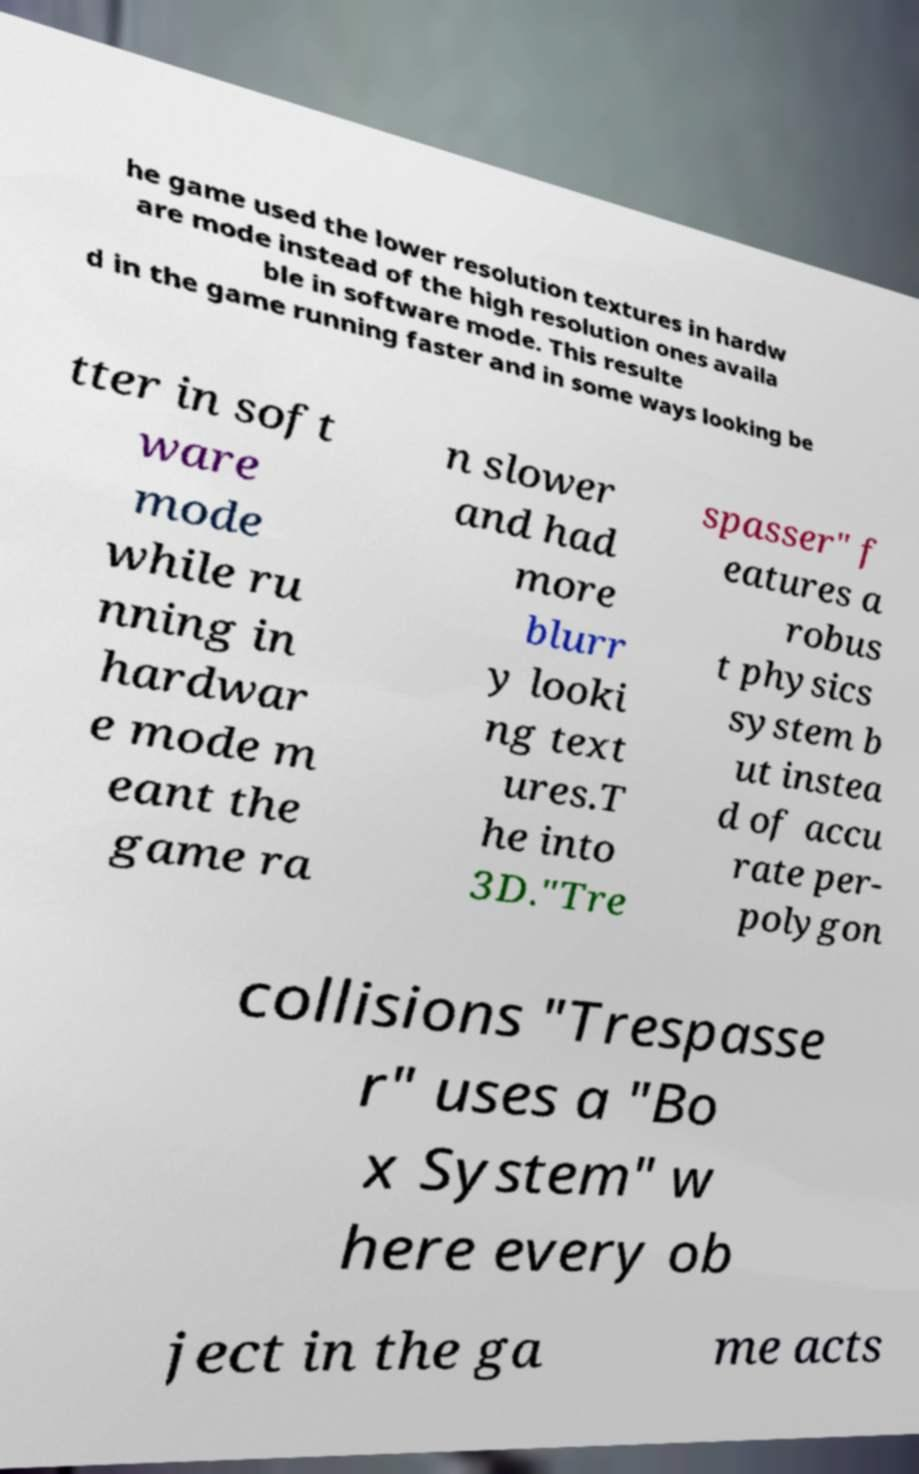For documentation purposes, I need the text within this image transcribed. Could you provide that? he game used the lower resolution textures in hardw are mode instead of the high resolution ones availa ble in software mode. This resulte d in the game running faster and in some ways looking be tter in soft ware mode while ru nning in hardwar e mode m eant the game ra n slower and had more blurr y looki ng text ures.T he into 3D."Tre spasser" f eatures a robus t physics system b ut instea d of accu rate per- polygon collisions "Trespasse r" uses a "Bo x System" w here every ob ject in the ga me acts 